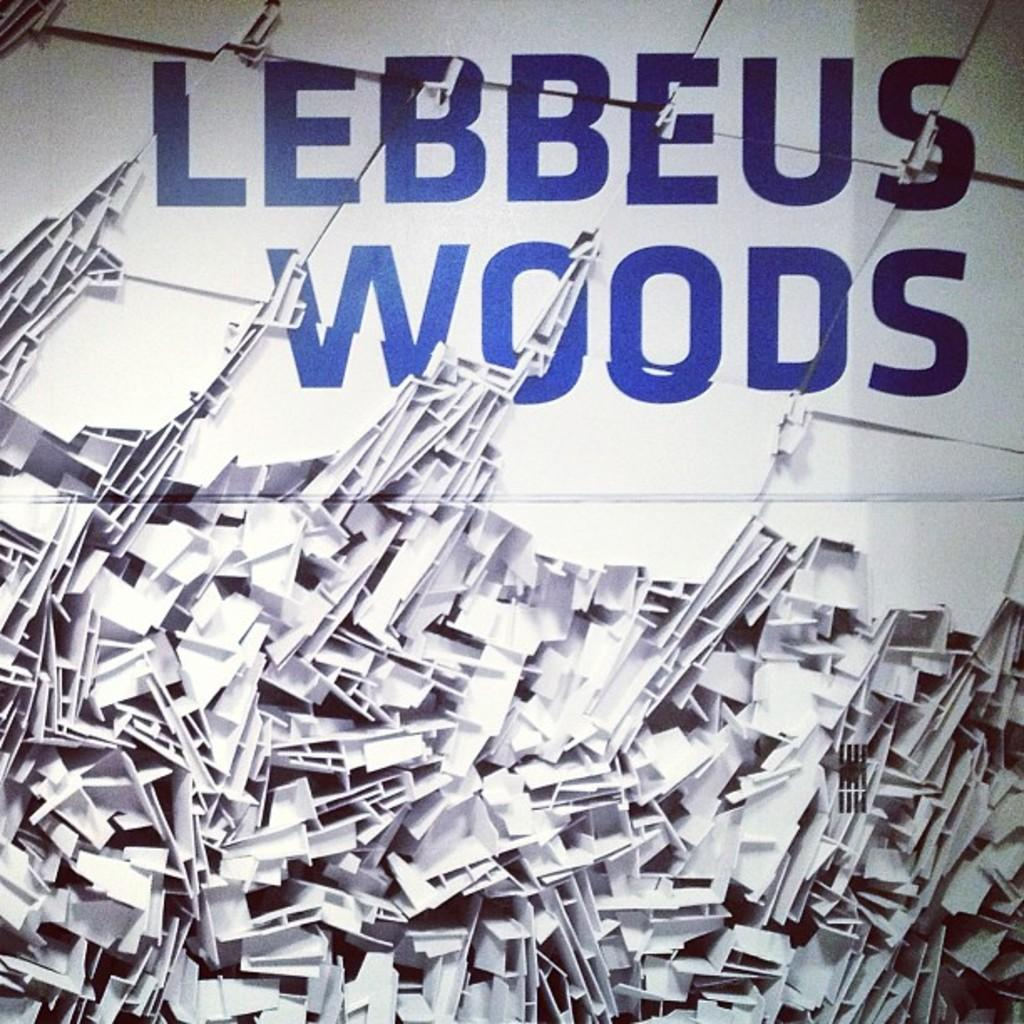What can be found at the bottom of the image? There are objects at the bottom of the image. What is located at the top of the image? There is text at the top of the image. How many pets can be seen playing with a pancake in the image? There are no pets or pancakes present in the image. What type of spiders are crawling on the text at the top of the image? There are no spiders present in the image, and therefore no such activity can be observed. 